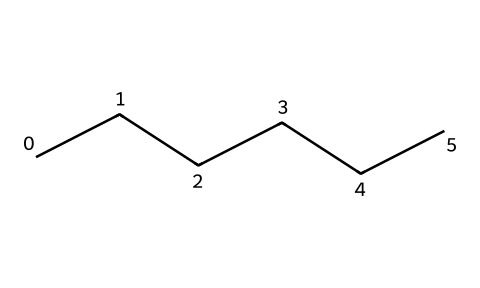What is the molecular formula of hexane? The molecular structure shows six carbon atoms connected in a chain, and each carbon is bonded to hydrogen atoms. Since hexane has six carbon atoms (C6), we can determine the number of hydrogen atoms by the formula CnH2n+2, where n is the number of carbon atoms. Here, n is 6, so the hydrogen count is 2(6)+2 = 14. Therefore, the molecular formula is C6H14.
Answer: C6H14 How many carbon atoms are in hexane? The structure displays a straight chain of six carbon atoms, indicating the number of carbon constituents present in the molecule.
Answer: 6 What is the primary functional group in hexane? Hexane is an alkane, which is characterized by having only single bonds between carbon atoms and lacks functional groups such as alcohols, ethers, or amines. Therefore, it is defined by its alkane status, which suggests no specific functional groups are present.
Answer: none How many hydrogen atoms can hexane bond with? By examining the molecular formula (C6H14), we identify the total number of hydrogen atoms directly associated with the six carbon atoms as indicated by the formula structure, which provides the precise count of hydrogen.
Answer: 14 What type of chemical bonding is present in hexane? The structure of hexane shows that all carbon atoms are connected through single covalent bonds, which is characteristic of aliphatic compounds. Since there are no multiple bonds (double or triple) present, it confirms the presence of only single bonds.
Answer: single covalent bonds Is hexane considered a saturated or unsaturated compound? Given the absence of double or triple bonds (as observed through the single bonding between carbon atoms), hexane falls under the category of saturated hydrocarbons, which means it is saturated with hydrogen atoms.
Answer: saturated What region of the chemical structure defines it as an aliphatic compound? The straight-chain arrangement of carbon atoms without any rings or functional groups indicates that hexane is aliphatic. Aliphatic compounds consist of linear or branched chains of carbon, as represented in this molecular structure.
Answer: straight-chain carbon 